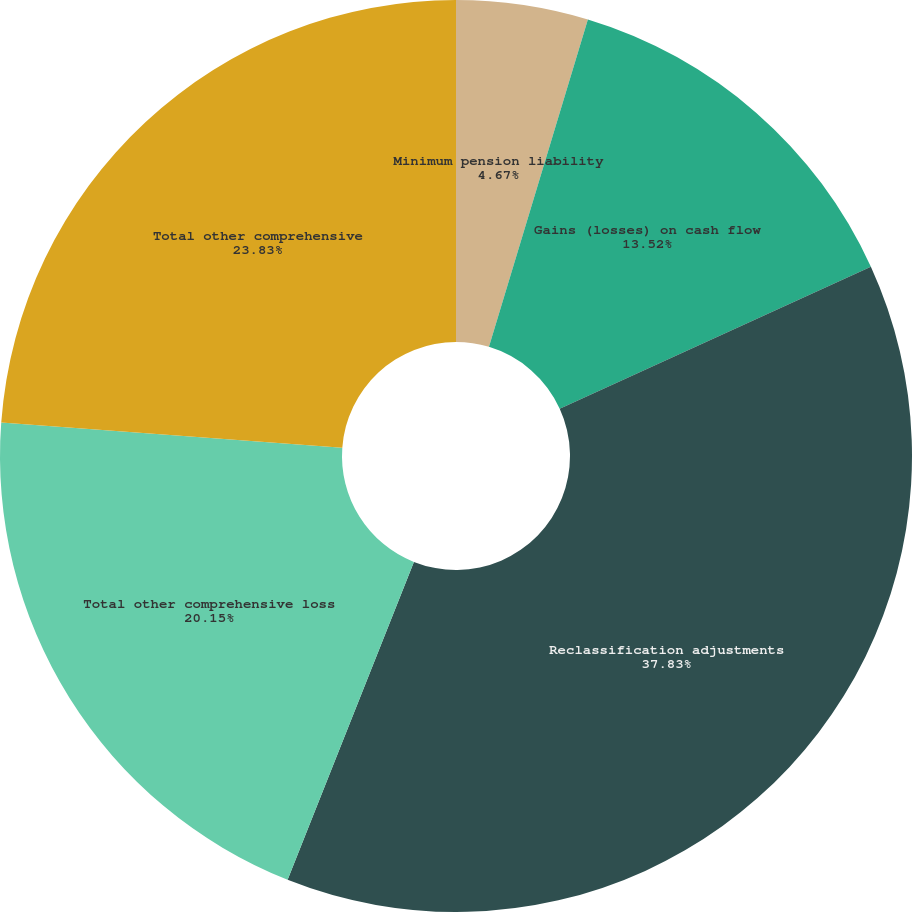Convert chart to OTSL. <chart><loc_0><loc_0><loc_500><loc_500><pie_chart><fcel>Minimum pension liability<fcel>Gains (losses) on cash flow<fcel>Reclassification adjustments<fcel>Total other comprehensive loss<fcel>Total other comprehensive<nl><fcel>4.67%<fcel>13.52%<fcel>37.83%<fcel>20.15%<fcel>23.83%<nl></chart> 